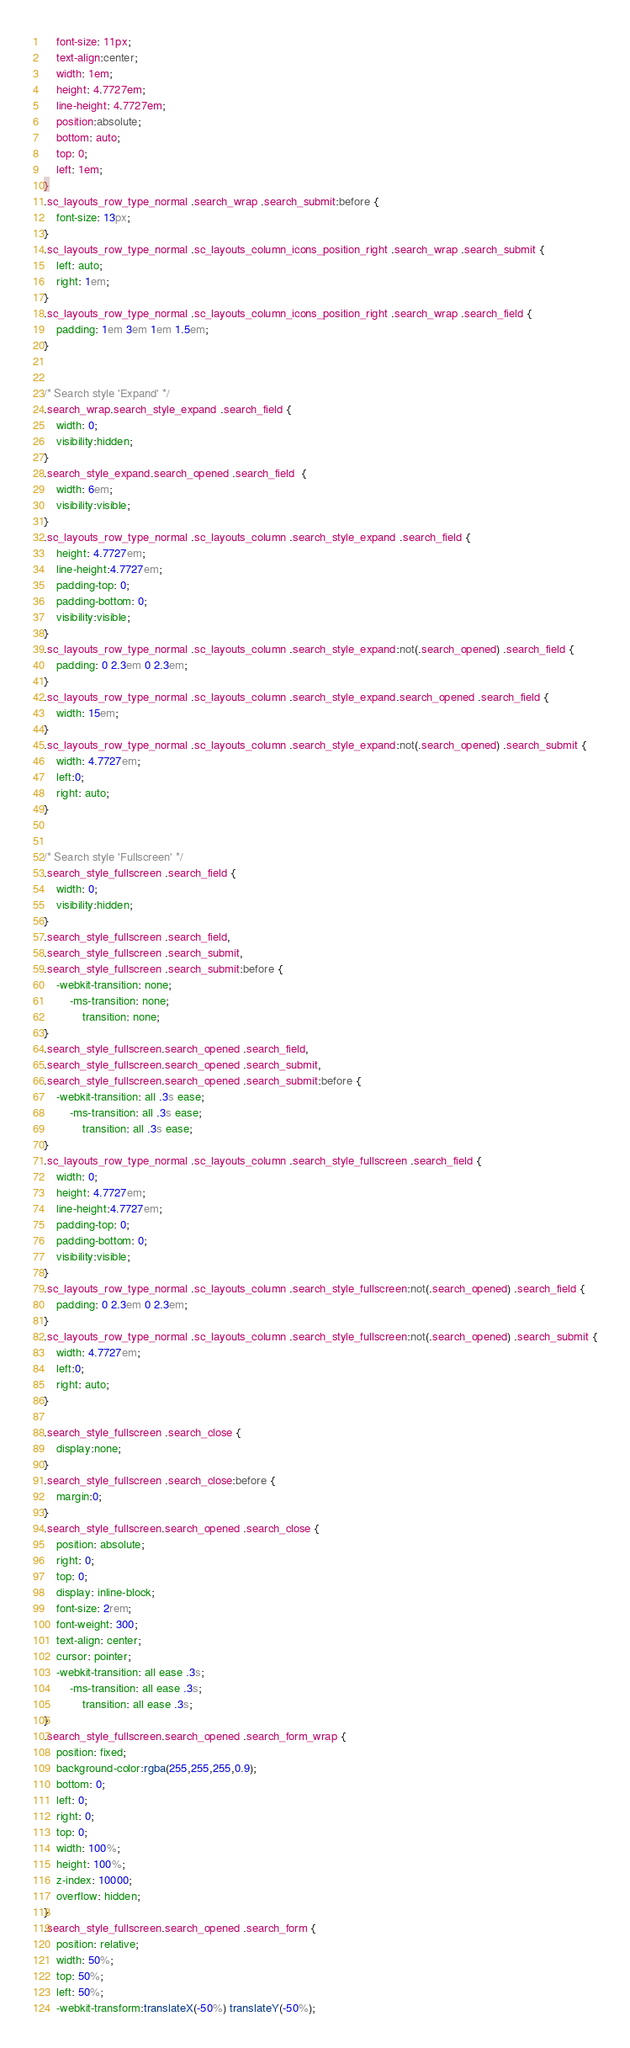Convert code to text. <code><loc_0><loc_0><loc_500><loc_500><_CSS_>	font-size: 11px;
	text-align:center;
	width: 1em;
	height: 4.7727em;
	line-height: 4.7727em;
	position:absolute;
	bottom: auto;
	top: 0;
	left: 1em;
}
.sc_layouts_row_type_normal .search_wrap .search_submit:before {
	font-size: 13px;
}
.sc_layouts_row_type_normal .sc_layouts_column_icons_position_right .search_wrap .search_submit {
	left: auto;
	right: 1em;
}
.sc_layouts_row_type_normal .sc_layouts_column_icons_position_right .search_wrap .search_field {
	padding: 1em 3em 1em 1.5em;
}


/* Search style 'Expand' */
.search_wrap.search_style_expand .search_field {
	width: 0;
	visibility:hidden;
}
.search_style_expand.search_opened .search_field  {
	width: 6em;
	visibility:visible;
}
.sc_layouts_row_type_normal .sc_layouts_column .search_style_expand .search_field {
	height: 4.7727em;
	line-height:4.7727em;
	padding-top: 0;
	padding-bottom: 0;
	visibility:visible;
}
.sc_layouts_row_type_normal .sc_layouts_column .search_style_expand:not(.search_opened) .search_field {
	padding: 0 2.3em 0 2.3em;
}
.sc_layouts_row_type_normal .sc_layouts_column .search_style_expand.search_opened .search_field {
	width: 15em;
}
.sc_layouts_row_type_normal .sc_layouts_column .search_style_expand:not(.search_opened) .search_submit {
	width: 4.7727em;
	left:0;
	right: auto;
}


/* Search style 'Fullscreen' */
.search_style_fullscreen .search_field {
	width: 0;
	visibility:hidden;
}
.search_style_fullscreen .search_field,
.search_style_fullscreen .search_submit,
.search_style_fullscreen .search_submit:before {
	-webkit-transition: none;
	    -ms-transition: none;
			transition: none;
}
.search_style_fullscreen.search_opened .search_field,
.search_style_fullscreen.search_opened .search_submit,
.search_style_fullscreen.search_opened .search_submit:before {
	-webkit-transition: all .3s ease;
	    -ms-transition: all .3s ease;
			transition: all .3s ease;
}
.sc_layouts_row_type_normal .sc_layouts_column .search_style_fullscreen .search_field {
	width: 0;
	height: 4.7727em;
	line-height:4.7727em;
	padding-top: 0;
	padding-bottom: 0;
	visibility:visible;
}
.sc_layouts_row_type_normal .sc_layouts_column .search_style_fullscreen:not(.search_opened) .search_field {
	padding: 0 2.3em 0 2.3em;
}
.sc_layouts_row_type_normal .sc_layouts_column .search_style_fullscreen:not(.search_opened) .search_submit {
	width: 4.7727em;
	left:0;
	right: auto;
}

.search_style_fullscreen .search_close {
	display:none;
}
.search_style_fullscreen .search_close:before {
	margin:0;
}
.search_style_fullscreen.search_opened .search_close {
	position: absolute;
	right: 0;
	top: 0;
	display: inline-block;
	font-size: 2rem;
	font-weight: 300;
	text-align: center;
	cursor: pointer;
	-webkit-transition: all ease .3s;
	    -ms-transition: all ease .3s;
			transition: all ease .3s;
}
.search_style_fullscreen.search_opened .search_form_wrap {
	position: fixed;
	background-color:rgba(255,255,255,0.9);
	bottom: 0;
	left: 0;
	right: 0;
	top: 0;
	width: 100%;
	height: 100%;
	z-index: 10000;
	overflow: hidden;
}
.search_style_fullscreen.search_opened .search_form {
	position: relative;
	width: 50%;
	top: 50%;
	left: 50%;
	-webkit-transform:translateX(-50%) translateY(-50%);</code> 